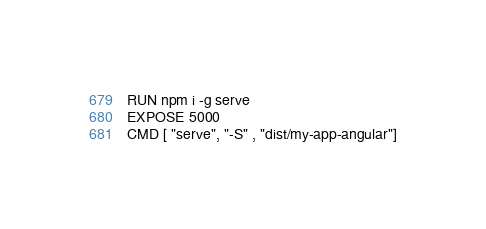Convert code to text. <code><loc_0><loc_0><loc_500><loc_500><_Dockerfile_>RUN npm i -g serve
EXPOSE 5000
CMD [ "serve", "-S" , "dist/my-app-angular"]
</code> 